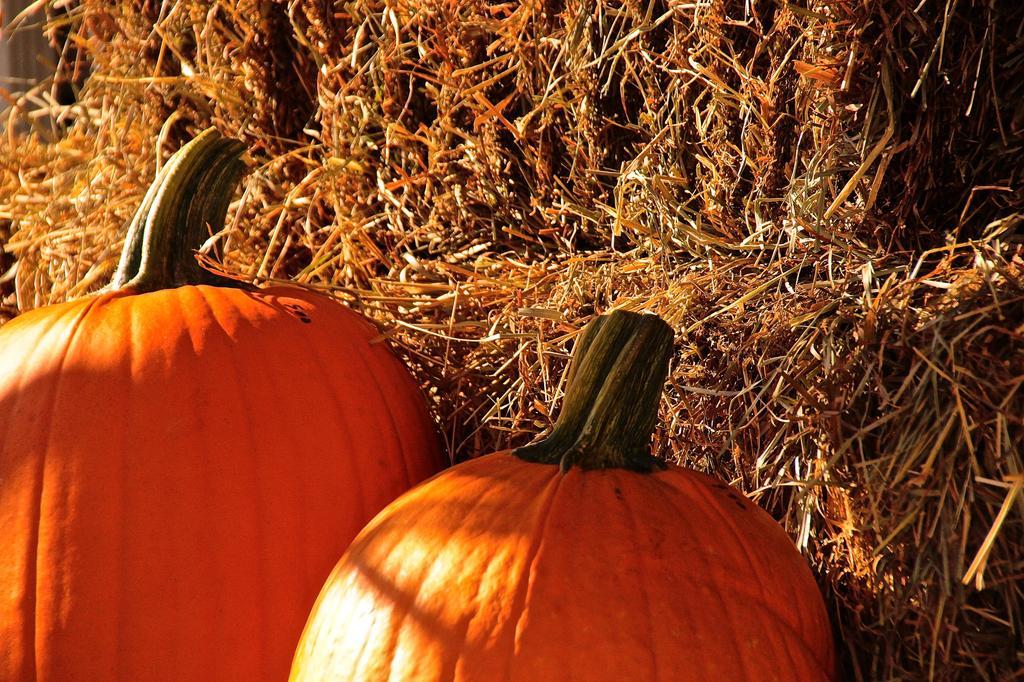Can you describe this image briefly? In this picture we can see two pumpkins in the front, in the background we can see grass. 